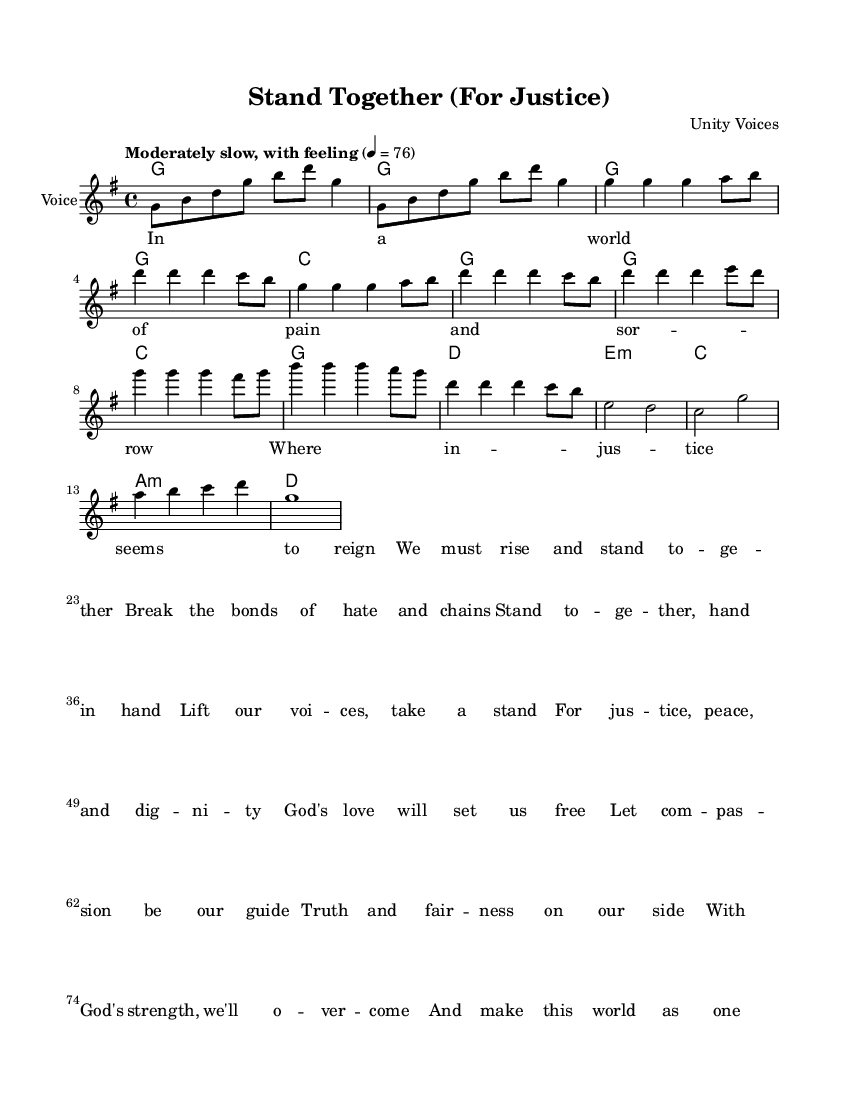What is the key signature of this music? The key signature is indicated at the beginning of the score, which shows one sharp (F#), thus identifying the key as G major.
Answer: G major What is the time signature of this music? The time signature is noted near the beginning of the score as 4/4, indicating four beats per measure.
Answer: 4/4 What is the tempo marking for this piece? The tempo marking is found at the beginning and states "Moderately slow, with feeling" and a metronome marking of quarter note equals 76.
Answer: Moderately slow, with feeling How many measures are in the melody section of the score? By counting the measures in the "melody" part, we see there are a total of 16 measures in the melody section.
Answer: 16 measures Which vocal quality is indicated for the instrument section of the score? The score indicates "Voice" as the instrument name, denoting that it is meant for vocal performance.
Answer: Voice In which section of the music do we find the lyrics related to social justice? The lyrics can be found in the "verse" block, which focuses on themes of justice, compassion, and unity.
Answer: Verse What is the main theme of the lyrics presented in this score? By analyzing the lyrics, we can determine that the main theme centers on standing together for justice, peace, and dignity.
Answer: Justice, peace, and dignity 